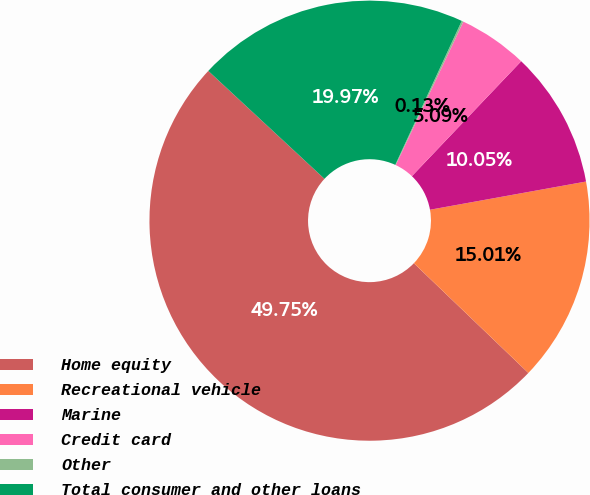Convert chart. <chart><loc_0><loc_0><loc_500><loc_500><pie_chart><fcel>Home equity<fcel>Recreational vehicle<fcel>Marine<fcel>Credit card<fcel>Other<fcel>Total consumer and other loans<nl><fcel>49.75%<fcel>15.01%<fcel>10.05%<fcel>5.09%<fcel>0.13%<fcel>19.97%<nl></chart> 